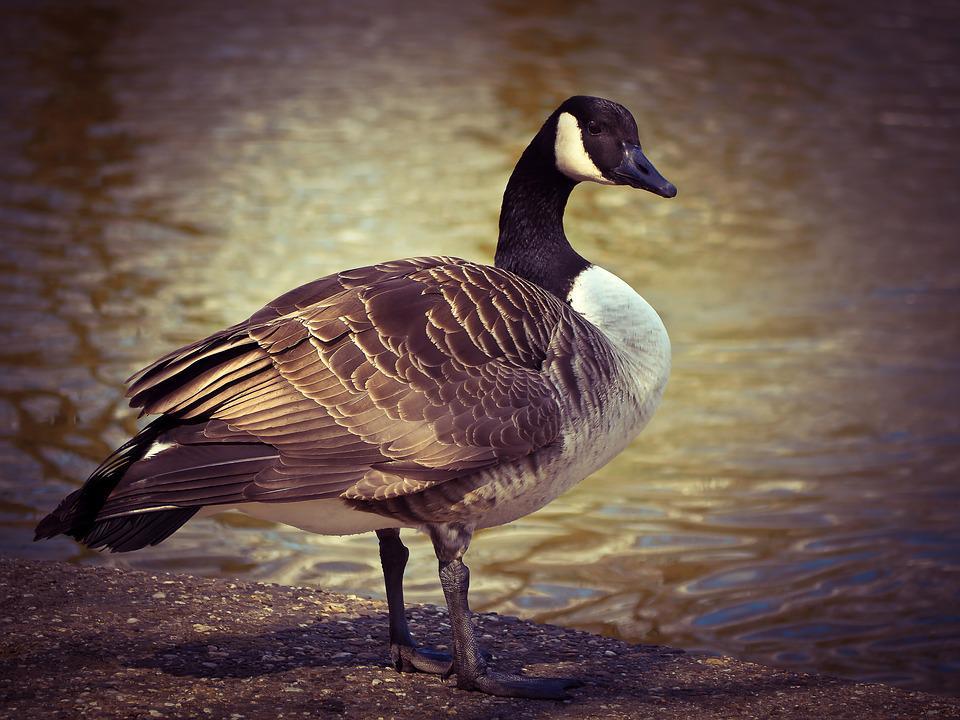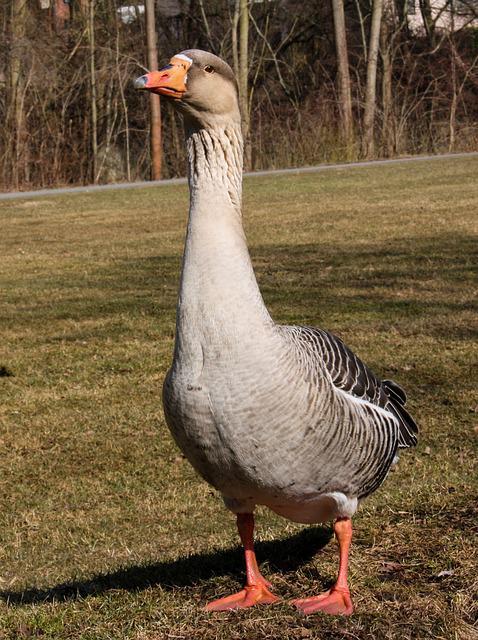The first image is the image on the left, the second image is the image on the right. Assess this claim about the two images: "All the ducks in the image are facing the same direction.". Correct or not? Answer yes or no. No. 